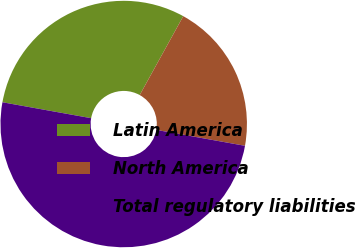Convert chart to OTSL. <chart><loc_0><loc_0><loc_500><loc_500><pie_chart><fcel>Latin America<fcel>North America<fcel>Total regulatory liabilities<nl><fcel>30.2%<fcel>19.8%<fcel>50.0%<nl></chart> 